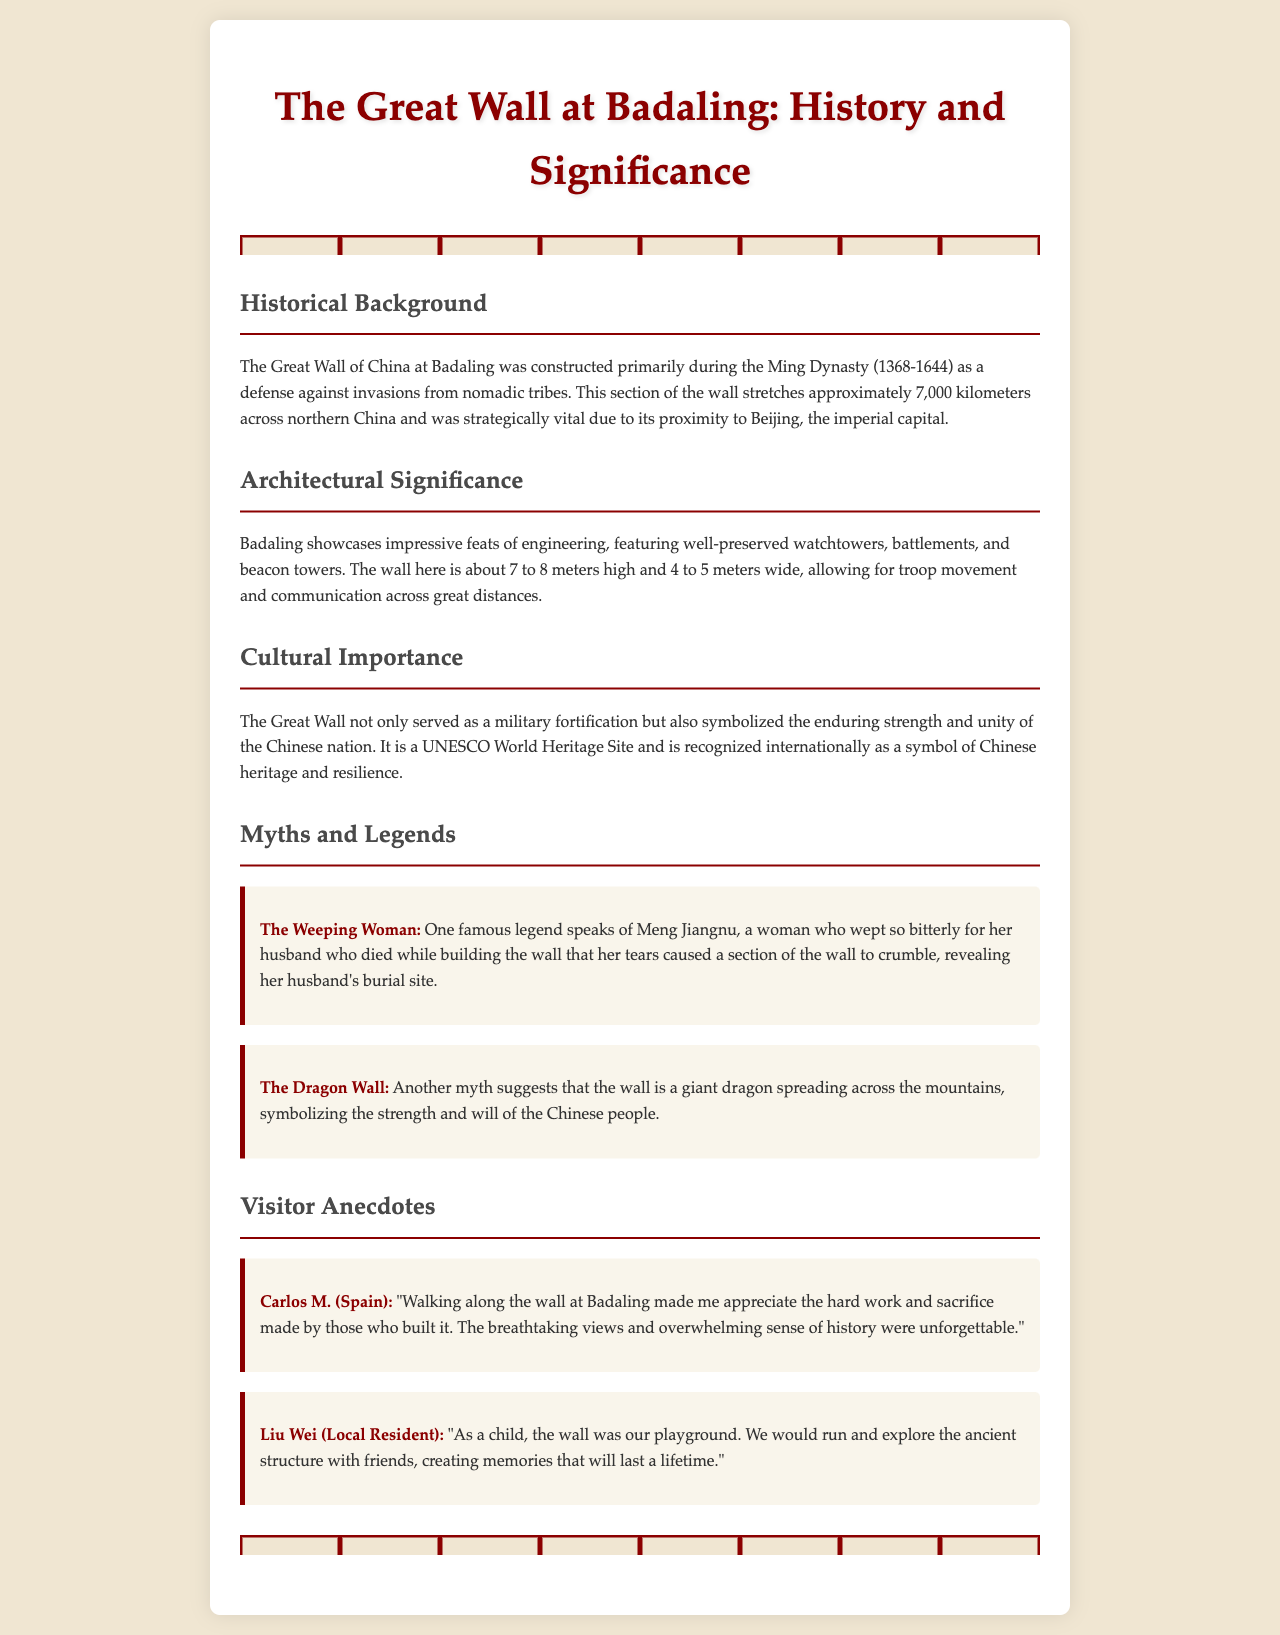What dynasty primarily constructed the Great Wall at Badaling? The document states that the wall was constructed primarily during the Ming Dynasty.
Answer: Ming Dynasty How high is the wall at Badaling? The document indicates that the wall is about 7 to 8 meters high.
Answer: 7 to 8 meters What is the significance of the Great Wall as mentioned in the document? The document highlights that the wall symbolizes the enduring strength and unity of the Chinese nation.
Answer: Enduring strength and unity Who is the woman associated with the legend of the Weeping Woman? The legend references Meng Jiangnu as the woman who wept for her husband.
Answer: Meng Jiangnu What did Carlos M. from Spain appreciate about the wall? According to Carlos M., he appreciated the hard work and sacrifice made by those who built it.
Answer: Hard work and sacrifice How long does the Great Wall stretch across northern China? The document specifies that the wall stretches approximately 7,000 kilometers across northern China.
Answer: 7,000 kilometers Which UNESCO status is attributed to the Great Wall? The document states that it is recognized as a UNESCO World Heritage Site.
Answer: UNESCO World Heritage Site What common childhood activity is mentioned by Liu Wei? Liu Wei mentions that he and his friends would run and explore the ancient structure.
Answer: Run and explore What does the myth of the Dragon Wall symbolize? The myth suggests that the wall symbolizes the strength and will of the Chinese people.
Answer: Strength and will of the Chinese people 